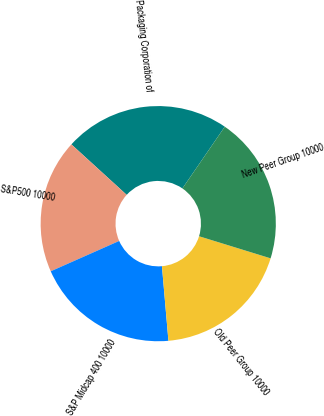Convert chart. <chart><loc_0><loc_0><loc_500><loc_500><pie_chart><fcel>Packaging Corporation of<fcel>S&P500 10000<fcel>S&P Midcap 400 10000<fcel>Old Peer Group 10000<fcel>New Peer Group 10000<nl><fcel>22.8%<fcel>18.41%<fcel>19.74%<fcel>18.85%<fcel>20.19%<nl></chart> 